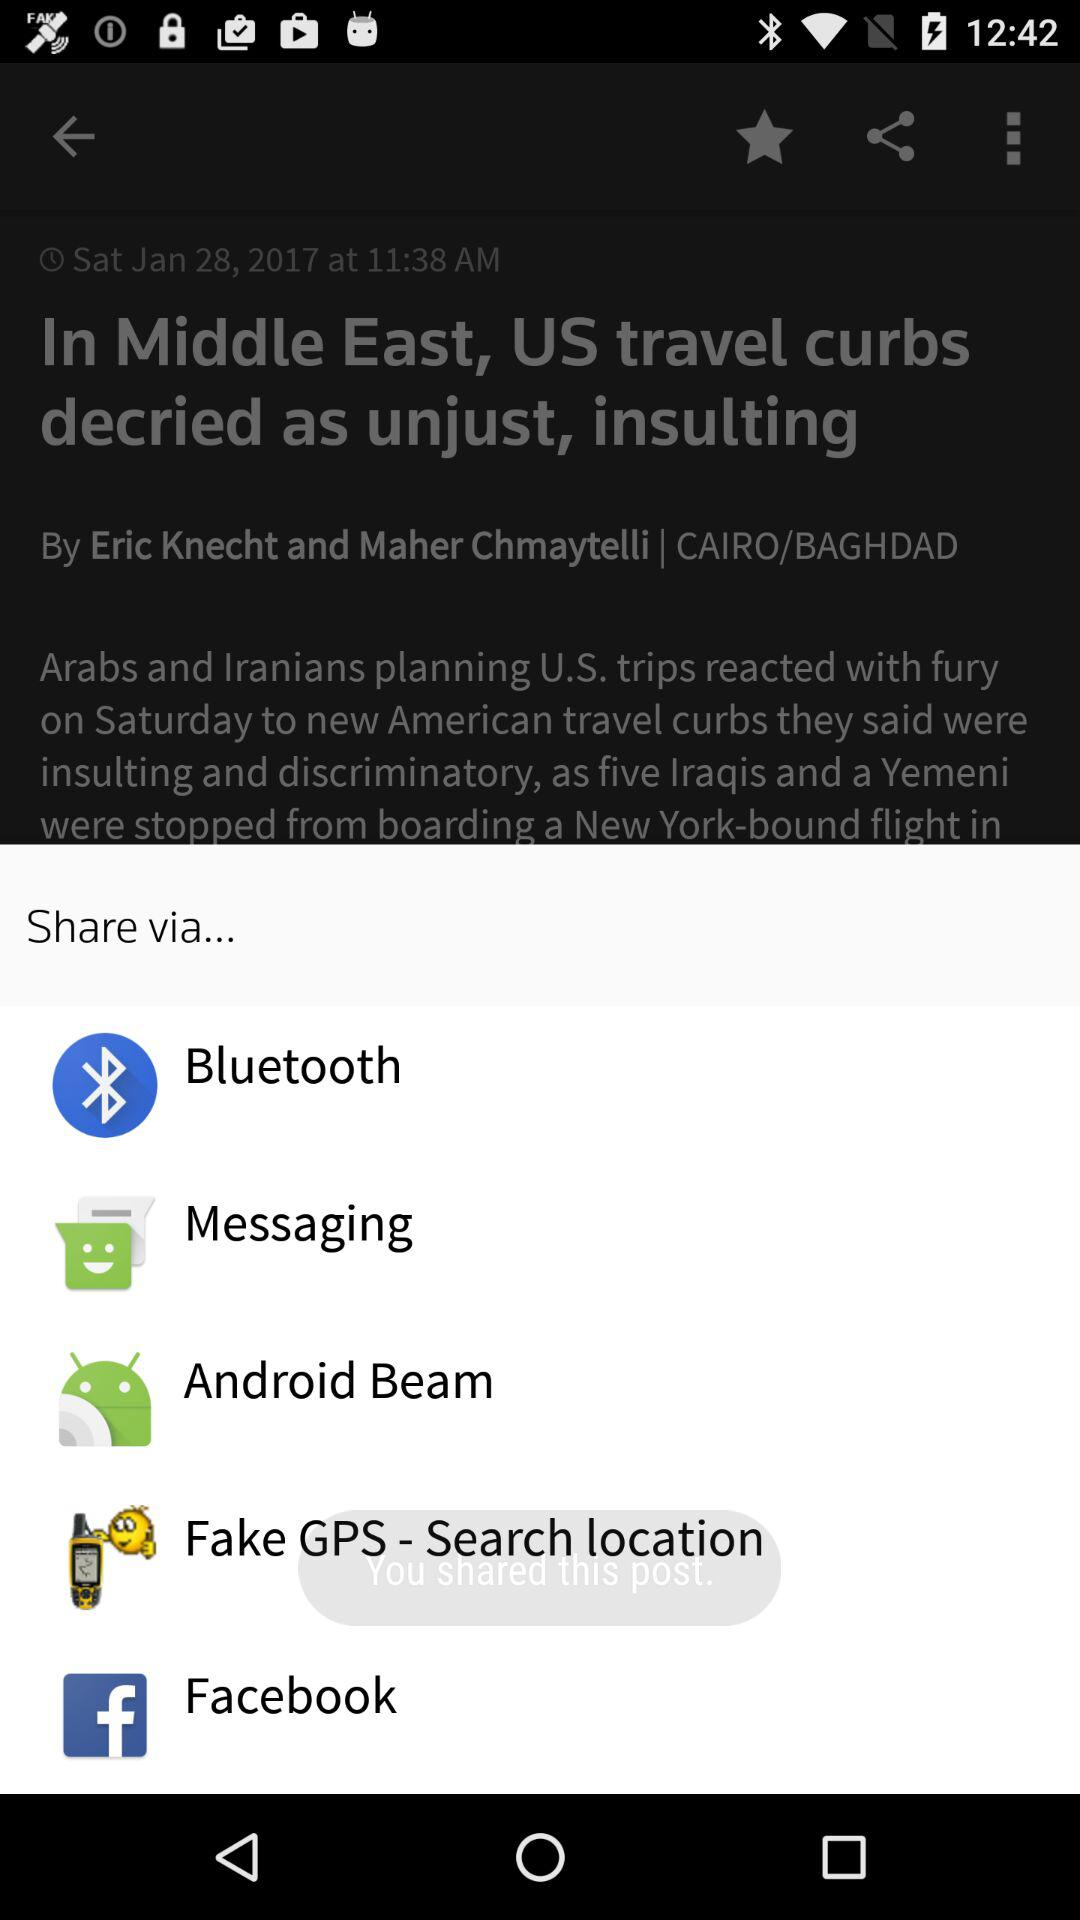What are the sharing options? The sharing options are "Bluetooth", "Messaging", "Android Beam", "Fake GPS - Search location" and "Facebook". 